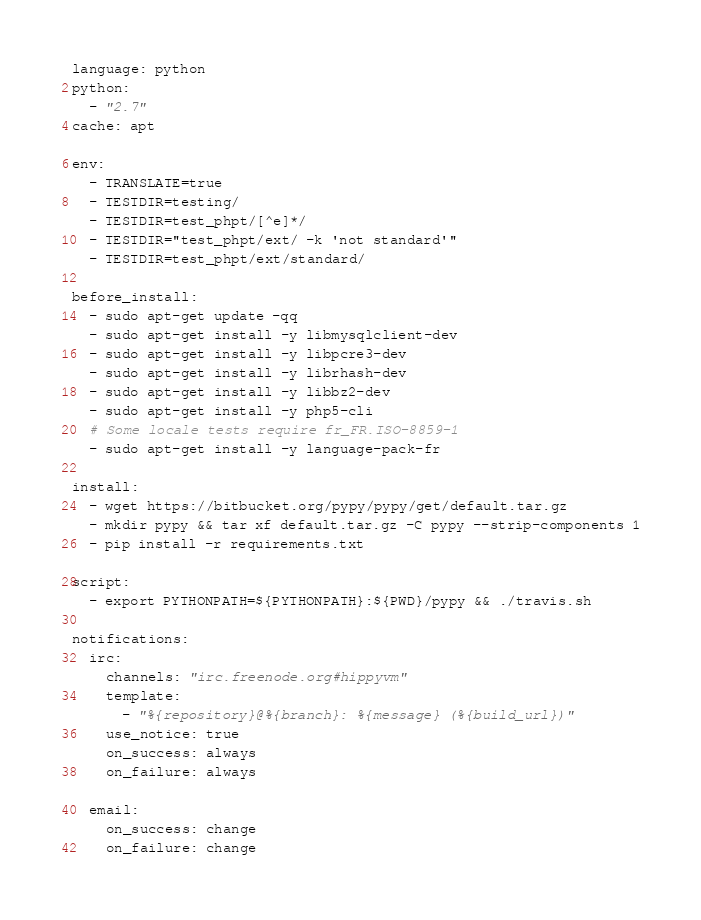<code> <loc_0><loc_0><loc_500><loc_500><_YAML_>language: python
python:
  - "2.7"
cache: apt

env:
  - TRANSLATE=true
  - TESTDIR=testing/
  - TESTDIR=test_phpt/[^e]*/
  - TESTDIR="test_phpt/ext/ -k 'not standard'"
  - TESTDIR=test_phpt/ext/standard/

before_install:
  - sudo apt-get update -qq
  - sudo apt-get install -y libmysqlclient-dev
  - sudo apt-get install -y libpcre3-dev
  - sudo apt-get install -y librhash-dev
  - sudo apt-get install -y libbz2-dev
  - sudo apt-get install -y php5-cli
  # Some locale tests require fr_FR.ISO-8859-1
  - sudo apt-get install -y language-pack-fr

install:
  - wget https://bitbucket.org/pypy/pypy/get/default.tar.gz
  - mkdir pypy && tar xf default.tar.gz -C pypy --strip-components 1
  - pip install -r requirements.txt

script:
  - export PYTHONPATH=${PYTHONPATH}:${PWD}/pypy && ./travis.sh

notifications:
  irc:
    channels: "irc.freenode.org#hippyvm"
    template:
      - "%{repository}@%{branch}: %{message} (%{build_url})"
    use_notice: true
    on_success: always
    on_failure: always

  email:
    on_success: change
    on_failure: change
</code> 